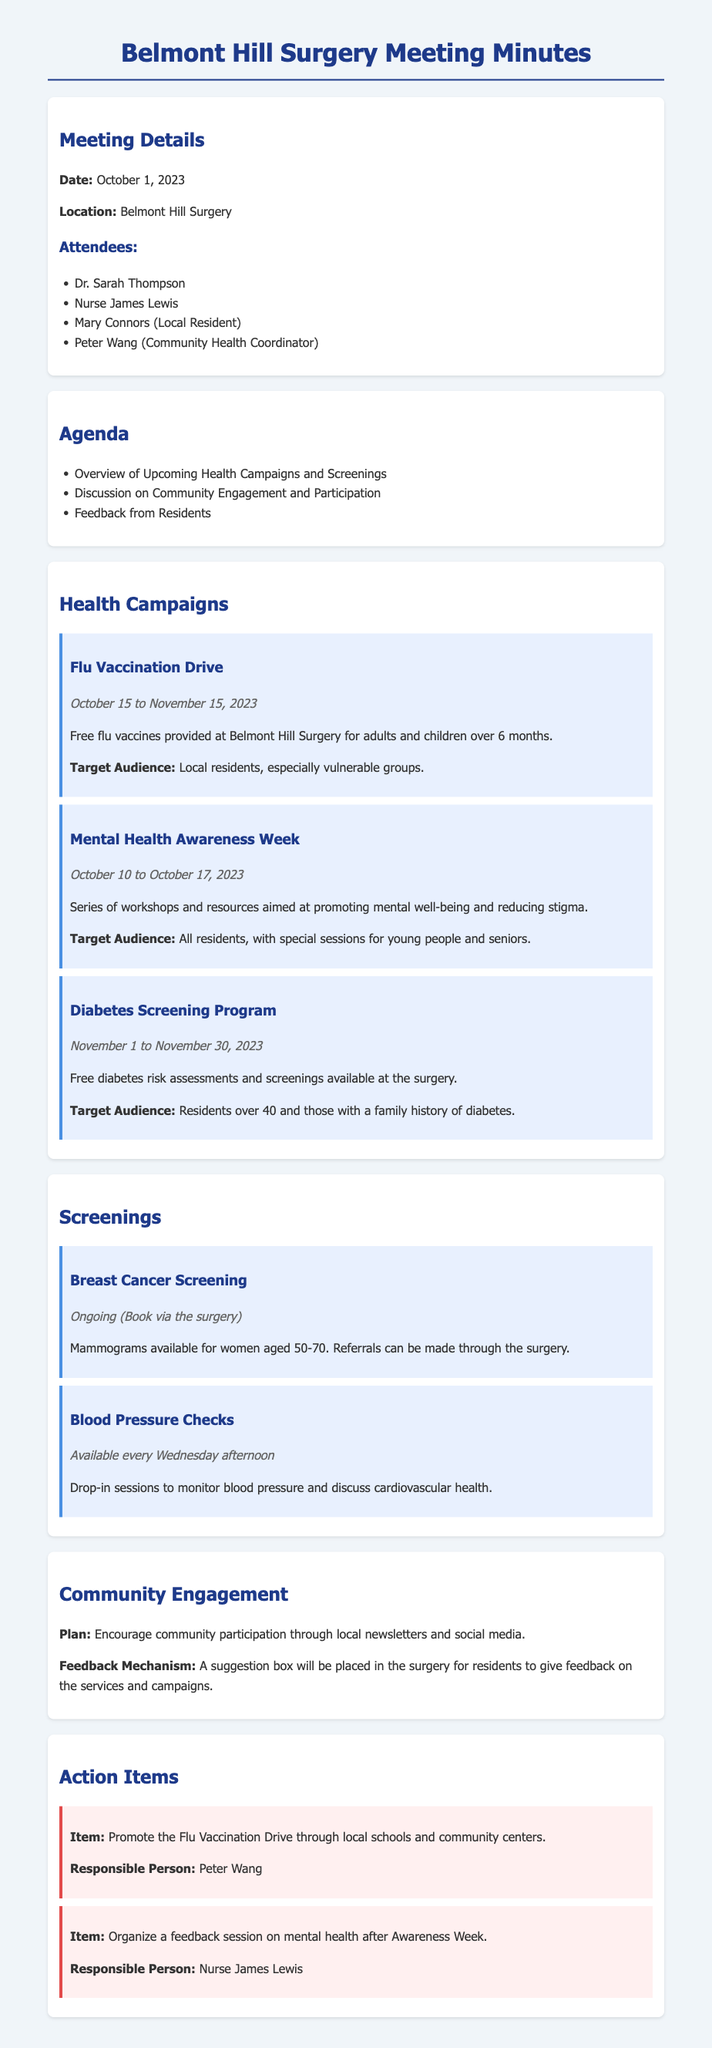What is the date for the Flu Vaccination Drive? The date for the Flu Vaccination Drive is mentioned in the section about health campaigns, running from October 15 to November 15, 2023.
Answer: October 15 to November 15, 2023 Who is responsible for promoting the Flu Vaccination Drive? The action item for promoting the Flu Vaccination Drive states that Peter Wang is the responsible person for this task.
Answer: Peter Wang What is the target audience for the Diabetes Screening Program? The document specifies the target audience for the Diabetes Screening Program as residents over 40 and those with a family history of diabetes.
Answer: Residents over 40 and those with a family history of diabetes How long does Mental Health Awareness Week last? The duration of Mental Health Awareness Week is detailed in the health campaigns section, occurring from October 10 to October 17, 2023.
Answer: October 10 to October 17, 2023 On which day are Blood Pressure Checks available? The document notes that Blood Pressure Checks are available every Wednesday afternoon.
Answer: Wednesday afternoon What feedback mechanism is mentioned in the community engagement section? The community engagement section describes that a suggestion box will be placed in the surgery for residents to give feedback on the services and campaigns.
Answer: Suggestion box What type of screening is available ongoing and requires booking through the surgery? The screening section indicates that Breast Cancer Screening is ongoing and requires booking via the surgery.
Answer: Breast Cancer Screening What is the focus of the Mental Health Awareness Week workshops? The document states that the focus is on promoting mental well-being and reducing stigma.
Answer: Promoting mental well-being and reducing stigma 